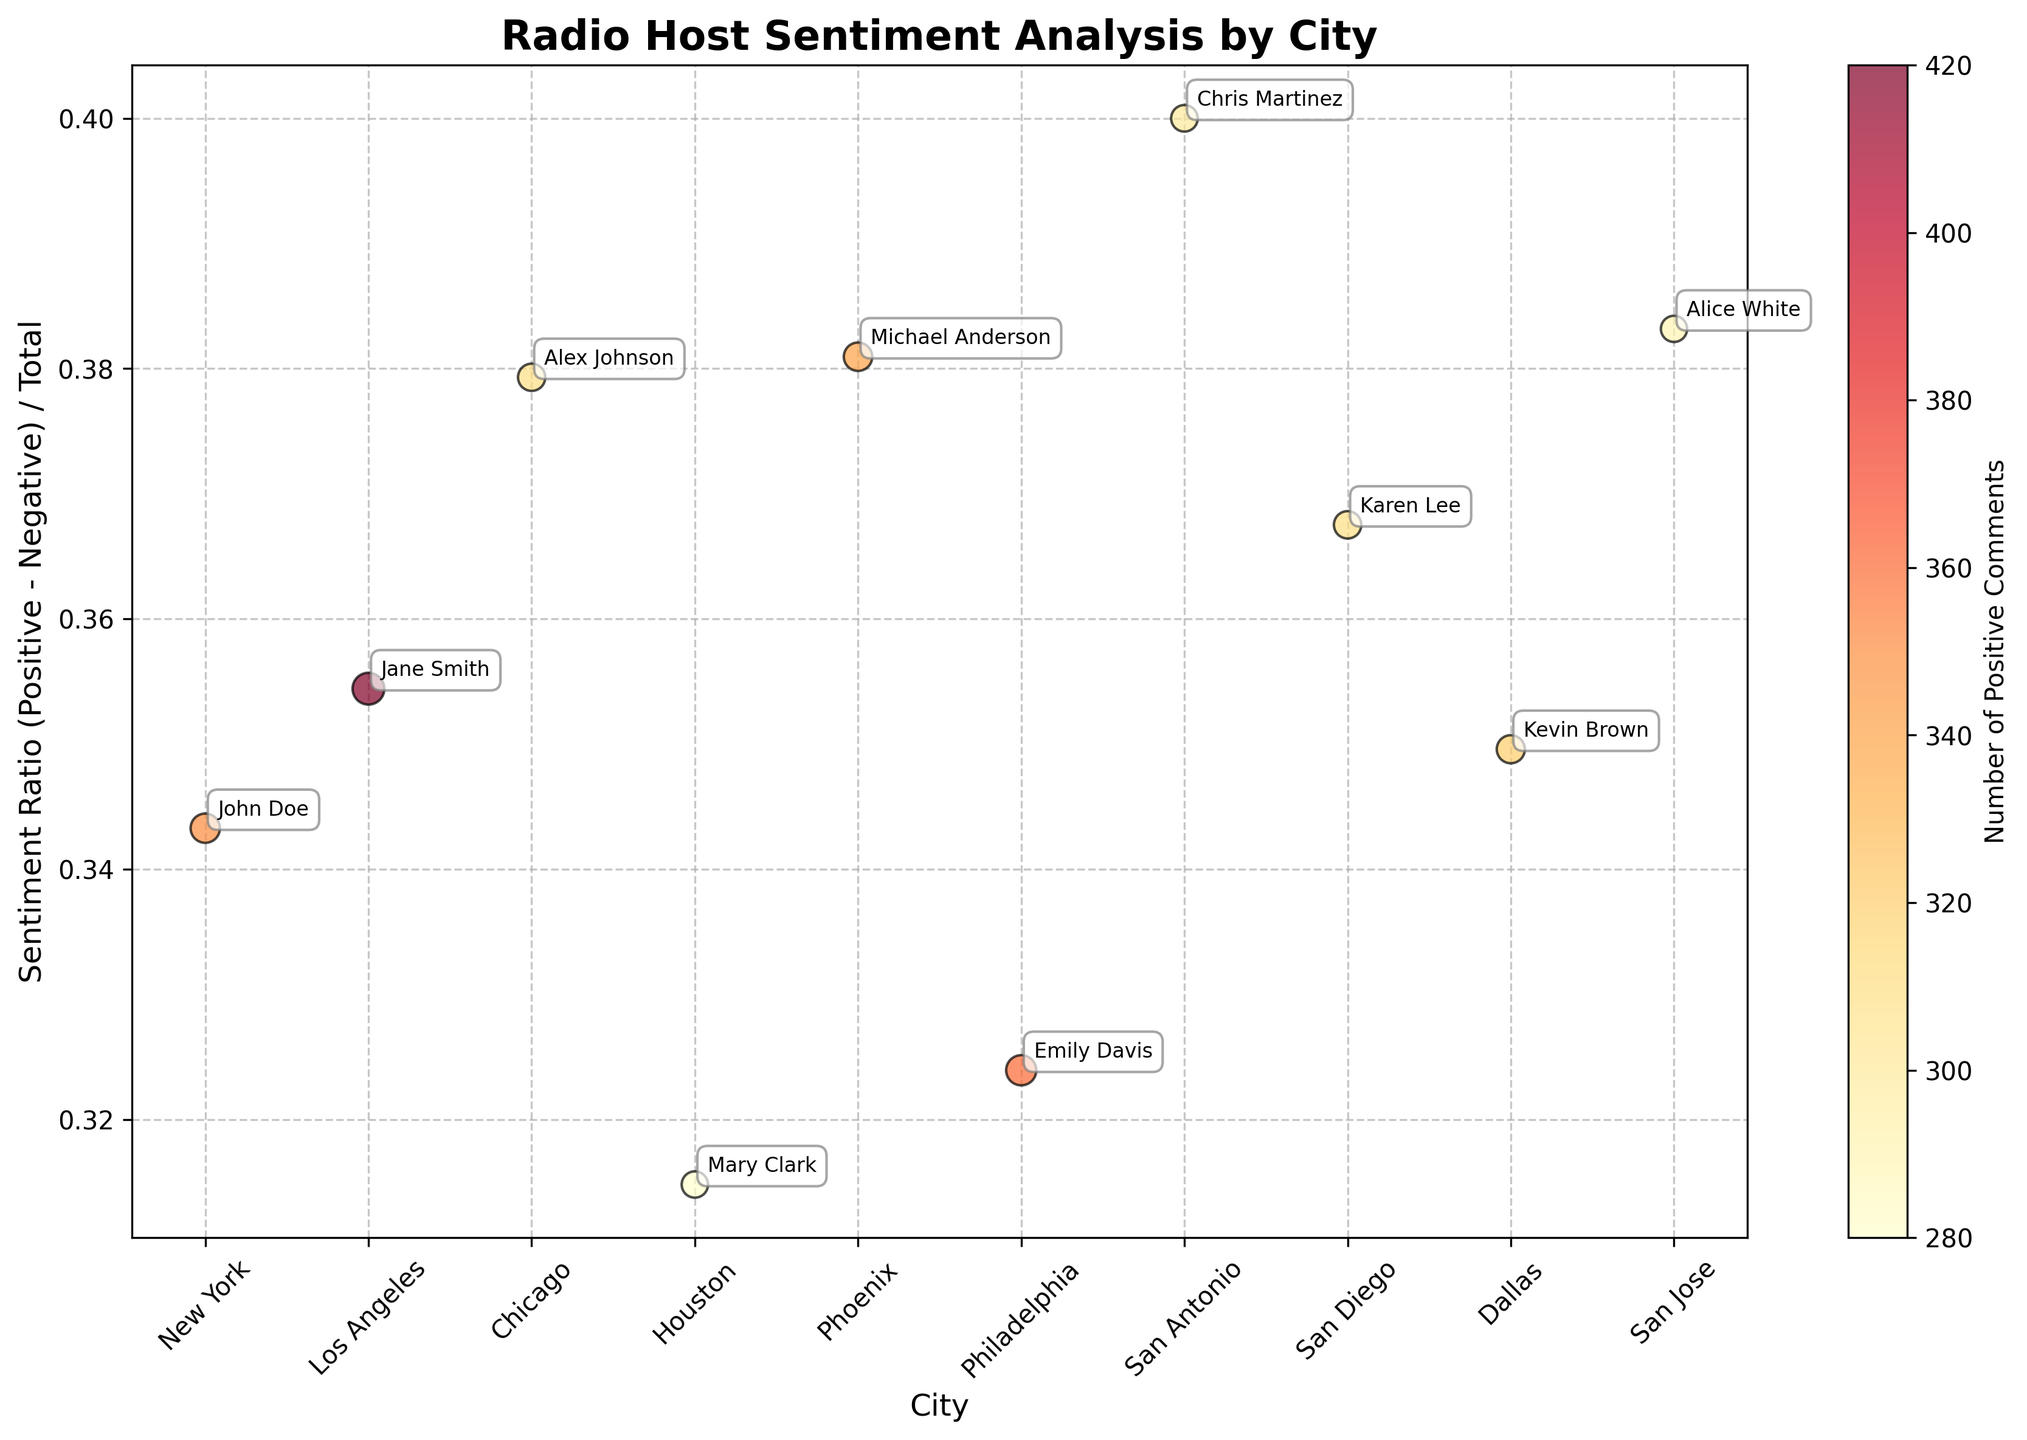What's the title of the figure? The title of the figure is typically located at the top of the chart. Here, the title reads "Radio Host Sentiment Analysis by City."
Answer: Radio Host Sentiment Analysis by City What does the x-axis represent? The x-axis is labeled "City," which indicates that the cities are represented along the horizontal axis of the chart.
Answer: City Which city has the radio host with the highest sentiment ratio? By examining the y-axis, which represents the sentiment ratio, the city with the radio host positioned highest on this axis has the highest sentiment ratio.
Answer: Los Angeles How many data points are depicted in the bubble chart? Each data point corresponds to a city, and there are individual bubbles for each city. Counting the bubbles gives the total number of data points.
Answer: 10 Which city has the radio host with the smallest bubble size? The bubble size is correlated with the total number of comments. The smallest bubble represents the city with the fewest total comments.
Answer: San Jose How many positive comments did the radio host in Philadelphia receive? The color bar represents the number of positive comments, and Philadelphia's bubble should be correlated with a specific color. The bubble also has an annotation that can help identify the number of positive comments.
Answer: 360 What is the sentiment ratio for the radio host in Chicago? Find the Chicago bubble on the chart and read its position on the y-axis to determine the sentiment ratio.
Answer: Approximately 0.55 Which city has a radio host with a sentiment ratio less than 0.5 and more positive comments than Houston? Cross-referencing the cities' bubbles, identify those with a sentiment ratio below 0.5. Then, among those, compare the positive comment counts using the color bar.
Answer: San Jose How does the size of the bubble in Dallas compare to that of New York? Comparing the visual sizes of the bubbles representing Dallas and New York will answer this. Larger bubbles indicate more total comments.
Answer: Dallas has a smaller bubble than New York Who is the radio host with the highest number of total comments? The largest bubble indicates the highest number of total comments. By identifying which bubble is largest, we can determine the radio host with the most comments.
Answer: Jane Smith 